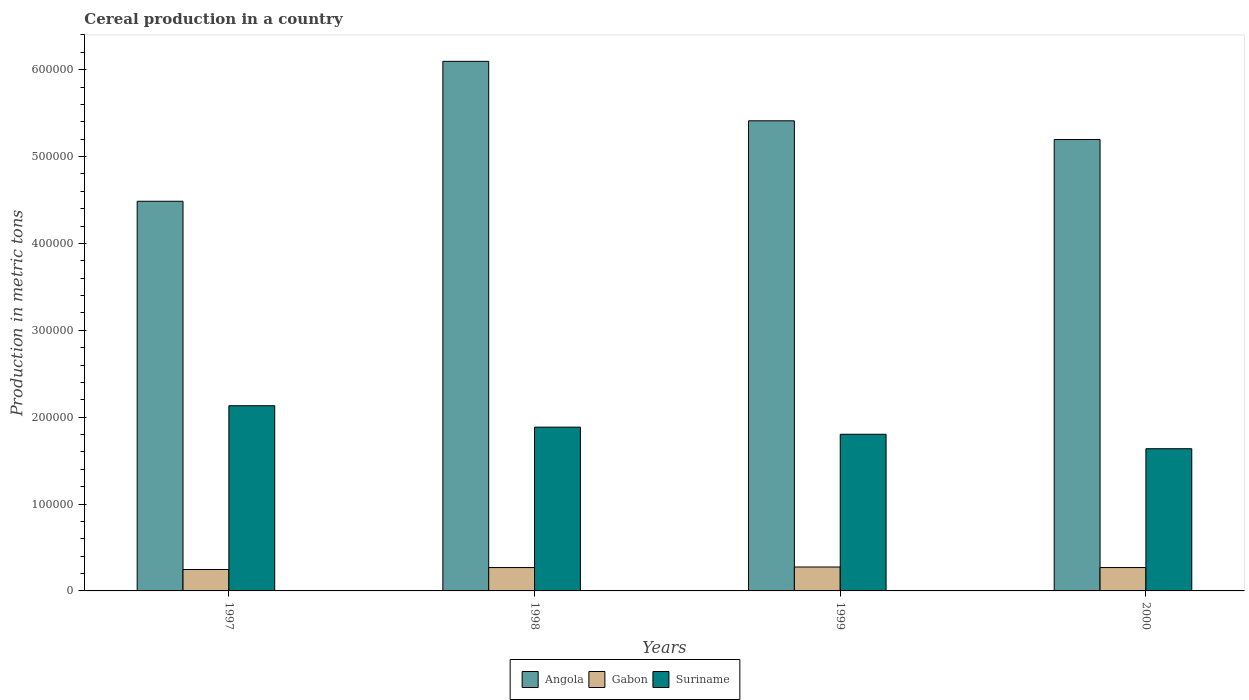How many different coloured bars are there?
Keep it short and to the point. 3. Are the number of bars per tick equal to the number of legend labels?
Offer a very short reply. Yes. How many bars are there on the 4th tick from the right?
Ensure brevity in your answer.  3. What is the label of the 1st group of bars from the left?
Offer a terse response. 1997. What is the total cereal production in Gabon in 2000?
Your answer should be compact. 2.69e+04. Across all years, what is the maximum total cereal production in Gabon?
Your response must be concise. 2.75e+04. Across all years, what is the minimum total cereal production in Angola?
Ensure brevity in your answer.  4.49e+05. What is the total total cereal production in Suriname in the graph?
Offer a terse response. 7.46e+05. What is the difference between the total cereal production in Gabon in 1997 and that in 2000?
Provide a short and direct response. -2254. What is the difference between the total cereal production in Gabon in 1998 and the total cereal production in Angola in 1999?
Give a very brief answer. -5.14e+05. What is the average total cereal production in Gabon per year?
Provide a succinct answer. 2.65e+04. In the year 1997, what is the difference between the total cereal production in Gabon and total cereal production in Angola?
Ensure brevity in your answer.  -4.24e+05. What is the ratio of the total cereal production in Suriname in 1997 to that in 2000?
Make the answer very short. 1.3. Is the difference between the total cereal production in Gabon in 1998 and 1999 greater than the difference between the total cereal production in Angola in 1998 and 1999?
Give a very brief answer. No. What is the difference between the highest and the second highest total cereal production in Angola?
Give a very brief answer. 6.84e+04. What is the difference between the highest and the lowest total cereal production in Suriname?
Keep it short and to the point. 4.95e+04. What does the 3rd bar from the left in 1998 represents?
Your answer should be very brief. Suriname. What does the 3rd bar from the right in 1998 represents?
Make the answer very short. Angola. Is it the case that in every year, the sum of the total cereal production in Angola and total cereal production in Gabon is greater than the total cereal production in Suriname?
Give a very brief answer. Yes. How many bars are there?
Your answer should be very brief. 12. How many years are there in the graph?
Your answer should be compact. 4. Does the graph contain grids?
Your answer should be compact. No. Where does the legend appear in the graph?
Make the answer very short. Bottom center. How many legend labels are there?
Your answer should be very brief. 3. How are the legend labels stacked?
Ensure brevity in your answer.  Horizontal. What is the title of the graph?
Your response must be concise. Cereal production in a country. What is the label or title of the X-axis?
Your response must be concise. Years. What is the label or title of the Y-axis?
Make the answer very short. Production in metric tons. What is the Production in metric tons in Angola in 1997?
Your answer should be compact. 4.49e+05. What is the Production in metric tons in Gabon in 1997?
Offer a terse response. 2.46e+04. What is the Production in metric tons in Suriname in 1997?
Provide a short and direct response. 2.13e+05. What is the Production in metric tons in Angola in 1998?
Make the answer very short. 6.10e+05. What is the Production in metric tons in Gabon in 1998?
Provide a succinct answer. 2.69e+04. What is the Production in metric tons of Suriname in 1998?
Make the answer very short. 1.89e+05. What is the Production in metric tons of Angola in 1999?
Offer a terse response. 5.41e+05. What is the Production in metric tons in Gabon in 1999?
Provide a succinct answer. 2.75e+04. What is the Production in metric tons of Suriname in 1999?
Your answer should be compact. 1.80e+05. What is the Production in metric tons in Angola in 2000?
Your answer should be very brief. 5.20e+05. What is the Production in metric tons of Gabon in 2000?
Provide a short and direct response. 2.69e+04. What is the Production in metric tons of Suriname in 2000?
Offer a very short reply. 1.64e+05. Across all years, what is the maximum Production in metric tons in Angola?
Make the answer very short. 6.10e+05. Across all years, what is the maximum Production in metric tons of Gabon?
Ensure brevity in your answer.  2.75e+04. Across all years, what is the maximum Production in metric tons in Suriname?
Your response must be concise. 2.13e+05. Across all years, what is the minimum Production in metric tons in Angola?
Provide a succinct answer. 4.49e+05. Across all years, what is the minimum Production in metric tons of Gabon?
Keep it short and to the point. 2.46e+04. Across all years, what is the minimum Production in metric tons in Suriname?
Keep it short and to the point. 1.64e+05. What is the total Production in metric tons of Angola in the graph?
Make the answer very short. 2.12e+06. What is the total Production in metric tons in Gabon in the graph?
Give a very brief answer. 1.06e+05. What is the total Production in metric tons in Suriname in the graph?
Offer a very short reply. 7.46e+05. What is the difference between the Production in metric tons in Angola in 1997 and that in 1998?
Provide a short and direct response. -1.61e+05. What is the difference between the Production in metric tons of Gabon in 1997 and that in 1998?
Provide a short and direct response. -2259. What is the difference between the Production in metric tons of Suriname in 1997 and that in 1998?
Provide a succinct answer. 2.47e+04. What is the difference between the Production in metric tons in Angola in 1997 and that in 1999?
Provide a short and direct response. -9.26e+04. What is the difference between the Production in metric tons of Gabon in 1997 and that in 1999?
Offer a very short reply. -2875. What is the difference between the Production in metric tons in Suriname in 1997 and that in 1999?
Your answer should be very brief. 3.29e+04. What is the difference between the Production in metric tons of Angola in 1997 and that in 2000?
Offer a very short reply. -7.11e+04. What is the difference between the Production in metric tons of Gabon in 1997 and that in 2000?
Your answer should be very brief. -2254. What is the difference between the Production in metric tons in Suriname in 1997 and that in 2000?
Offer a terse response. 4.95e+04. What is the difference between the Production in metric tons in Angola in 1998 and that in 1999?
Offer a very short reply. 6.84e+04. What is the difference between the Production in metric tons of Gabon in 1998 and that in 1999?
Ensure brevity in your answer.  -616. What is the difference between the Production in metric tons in Suriname in 1998 and that in 1999?
Provide a short and direct response. 8191. What is the difference between the Production in metric tons of Angola in 1998 and that in 2000?
Ensure brevity in your answer.  9.00e+04. What is the difference between the Production in metric tons of Gabon in 1998 and that in 2000?
Your answer should be compact. 5. What is the difference between the Production in metric tons in Suriname in 1998 and that in 2000?
Your answer should be very brief. 2.48e+04. What is the difference between the Production in metric tons in Angola in 1999 and that in 2000?
Provide a short and direct response. 2.15e+04. What is the difference between the Production in metric tons in Gabon in 1999 and that in 2000?
Make the answer very short. 621. What is the difference between the Production in metric tons in Suriname in 1999 and that in 2000?
Make the answer very short. 1.66e+04. What is the difference between the Production in metric tons in Angola in 1997 and the Production in metric tons in Gabon in 1998?
Your answer should be compact. 4.22e+05. What is the difference between the Production in metric tons of Angola in 1997 and the Production in metric tons of Suriname in 1998?
Make the answer very short. 2.60e+05. What is the difference between the Production in metric tons of Gabon in 1997 and the Production in metric tons of Suriname in 1998?
Provide a short and direct response. -1.64e+05. What is the difference between the Production in metric tons of Angola in 1997 and the Production in metric tons of Gabon in 1999?
Make the answer very short. 4.21e+05. What is the difference between the Production in metric tons in Angola in 1997 and the Production in metric tons in Suriname in 1999?
Make the answer very short. 2.68e+05. What is the difference between the Production in metric tons in Gabon in 1997 and the Production in metric tons in Suriname in 1999?
Ensure brevity in your answer.  -1.56e+05. What is the difference between the Production in metric tons in Angola in 1997 and the Production in metric tons in Gabon in 2000?
Ensure brevity in your answer.  4.22e+05. What is the difference between the Production in metric tons in Angola in 1997 and the Production in metric tons in Suriname in 2000?
Ensure brevity in your answer.  2.85e+05. What is the difference between the Production in metric tons in Gabon in 1997 and the Production in metric tons in Suriname in 2000?
Your response must be concise. -1.39e+05. What is the difference between the Production in metric tons in Angola in 1998 and the Production in metric tons in Gabon in 1999?
Offer a very short reply. 5.82e+05. What is the difference between the Production in metric tons in Angola in 1998 and the Production in metric tons in Suriname in 1999?
Give a very brief answer. 4.29e+05. What is the difference between the Production in metric tons in Gabon in 1998 and the Production in metric tons in Suriname in 1999?
Keep it short and to the point. -1.53e+05. What is the difference between the Production in metric tons in Angola in 1998 and the Production in metric tons in Gabon in 2000?
Keep it short and to the point. 5.83e+05. What is the difference between the Production in metric tons of Angola in 1998 and the Production in metric tons of Suriname in 2000?
Give a very brief answer. 4.46e+05. What is the difference between the Production in metric tons in Gabon in 1998 and the Production in metric tons in Suriname in 2000?
Provide a succinct answer. -1.37e+05. What is the difference between the Production in metric tons of Angola in 1999 and the Production in metric tons of Gabon in 2000?
Give a very brief answer. 5.14e+05. What is the difference between the Production in metric tons in Angola in 1999 and the Production in metric tons in Suriname in 2000?
Keep it short and to the point. 3.77e+05. What is the difference between the Production in metric tons in Gabon in 1999 and the Production in metric tons in Suriname in 2000?
Give a very brief answer. -1.36e+05. What is the average Production in metric tons in Angola per year?
Make the answer very short. 5.30e+05. What is the average Production in metric tons in Gabon per year?
Keep it short and to the point. 2.65e+04. What is the average Production in metric tons of Suriname per year?
Offer a terse response. 1.86e+05. In the year 1997, what is the difference between the Production in metric tons of Angola and Production in metric tons of Gabon?
Provide a succinct answer. 4.24e+05. In the year 1997, what is the difference between the Production in metric tons of Angola and Production in metric tons of Suriname?
Your response must be concise. 2.35e+05. In the year 1997, what is the difference between the Production in metric tons in Gabon and Production in metric tons in Suriname?
Offer a terse response. -1.89e+05. In the year 1998, what is the difference between the Production in metric tons of Angola and Production in metric tons of Gabon?
Your answer should be compact. 5.83e+05. In the year 1998, what is the difference between the Production in metric tons in Angola and Production in metric tons in Suriname?
Provide a short and direct response. 4.21e+05. In the year 1998, what is the difference between the Production in metric tons in Gabon and Production in metric tons in Suriname?
Your answer should be very brief. -1.62e+05. In the year 1999, what is the difference between the Production in metric tons of Angola and Production in metric tons of Gabon?
Give a very brief answer. 5.14e+05. In the year 1999, what is the difference between the Production in metric tons of Angola and Production in metric tons of Suriname?
Offer a terse response. 3.61e+05. In the year 1999, what is the difference between the Production in metric tons in Gabon and Production in metric tons in Suriname?
Provide a succinct answer. -1.53e+05. In the year 2000, what is the difference between the Production in metric tons of Angola and Production in metric tons of Gabon?
Ensure brevity in your answer.  4.93e+05. In the year 2000, what is the difference between the Production in metric tons in Angola and Production in metric tons in Suriname?
Ensure brevity in your answer.  3.56e+05. In the year 2000, what is the difference between the Production in metric tons in Gabon and Production in metric tons in Suriname?
Make the answer very short. -1.37e+05. What is the ratio of the Production in metric tons of Angola in 1997 to that in 1998?
Make the answer very short. 0.74. What is the ratio of the Production in metric tons of Gabon in 1997 to that in 1998?
Offer a terse response. 0.92. What is the ratio of the Production in metric tons of Suriname in 1997 to that in 1998?
Provide a succinct answer. 1.13. What is the ratio of the Production in metric tons in Angola in 1997 to that in 1999?
Provide a short and direct response. 0.83. What is the ratio of the Production in metric tons of Gabon in 1997 to that in 1999?
Provide a short and direct response. 0.9. What is the ratio of the Production in metric tons of Suriname in 1997 to that in 1999?
Make the answer very short. 1.18. What is the ratio of the Production in metric tons of Angola in 1997 to that in 2000?
Make the answer very short. 0.86. What is the ratio of the Production in metric tons in Gabon in 1997 to that in 2000?
Keep it short and to the point. 0.92. What is the ratio of the Production in metric tons of Suriname in 1997 to that in 2000?
Keep it short and to the point. 1.3. What is the ratio of the Production in metric tons of Angola in 1998 to that in 1999?
Provide a succinct answer. 1.13. What is the ratio of the Production in metric tons in Gabon in 1998 to that in 1999?
Ensure brevity in your answer.  0.98. What is the ratio of the Production in metric tons of Suriname in 1998 to that in 1999?
Offer a very short reply. 1.05. What is the ratio of the Production in metric tons of Angola in 1998 to that in 2000?
Offer a very short reply. 1.17. What is the ratio of the Production in metric tons of Suriname in 1998 to that in 2000?
Your answer should be very brief. 1.15. What is the ratio of the Production in metric tons in Angola in 1999 to that in 2000?
Make the answer very short. 1.04. What is the ratio of the Production in metric tons of Gabon in 1999 to that in 2000?
Provide a succinct answer. 1.02. What is the ratio of the Production in metric tons in Suriname in 1999 to that in 2000?
Your answer should be very brief. 1.1. What is the difference between the highest and the second highest Production in metric tons of Angola?
Ensure brevity in your answer.  6.84e+04. What is the difference between the highest and the second highest Production in metric tons in Gabon?
Ensure brevity in your answer.  616. What is the difference between the highest and the second highest Production in metric tons of Suriname?
Provide a succinct answer. 2.47e+04. What is the difference between the highest and the lowest Production in metric tons in Angola?
Provide a succinct answer. 1.61e+05. What is the difference between the highest and the lowest Production in metric tons in Gabon?
Your response must be concise. 2875. What is the difference between the highest and the lowest Production in metric tons of Suriname?
Your answer should be very brief. 4.95e+04. 